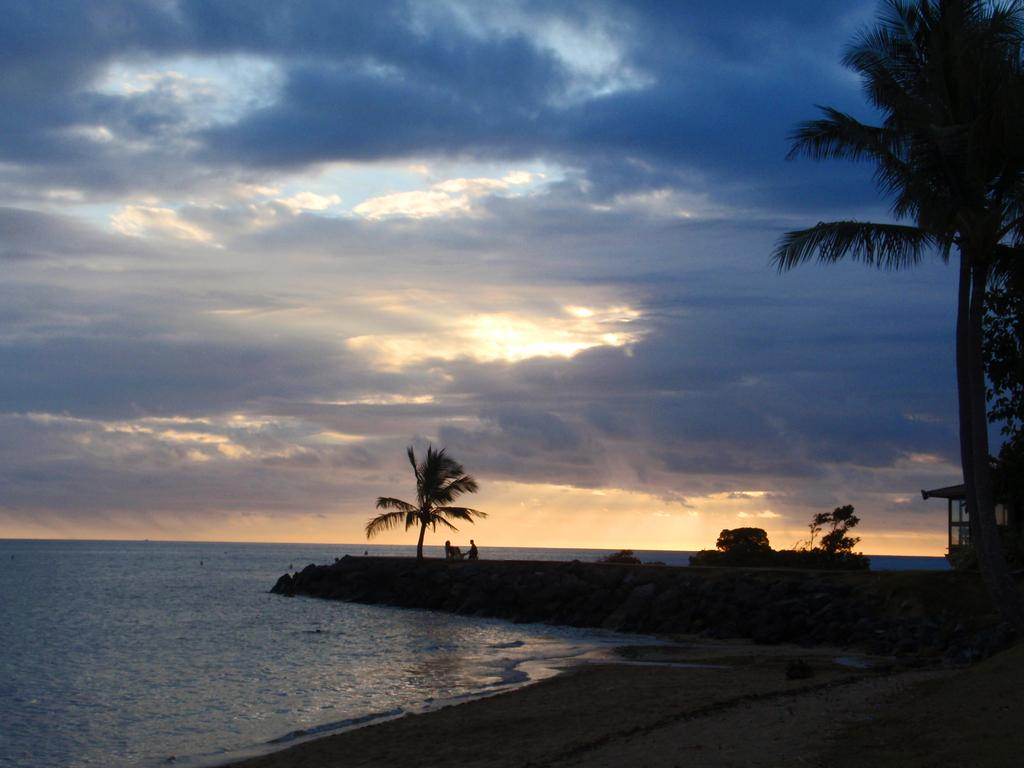What type of natural environment is depicted in the image? The image contains water, sand, and trees, which suggests a beach or coastal setting. How many people are present in the image? There are two persons in the image. What is visible in the background of the image? The sky is visible in the background of the image, and clouds are present in the sky. What type of plant is growing on the window in the image? There is no window or plant present in the image; it features a natural environment with water, sand, trees, and two persons. 